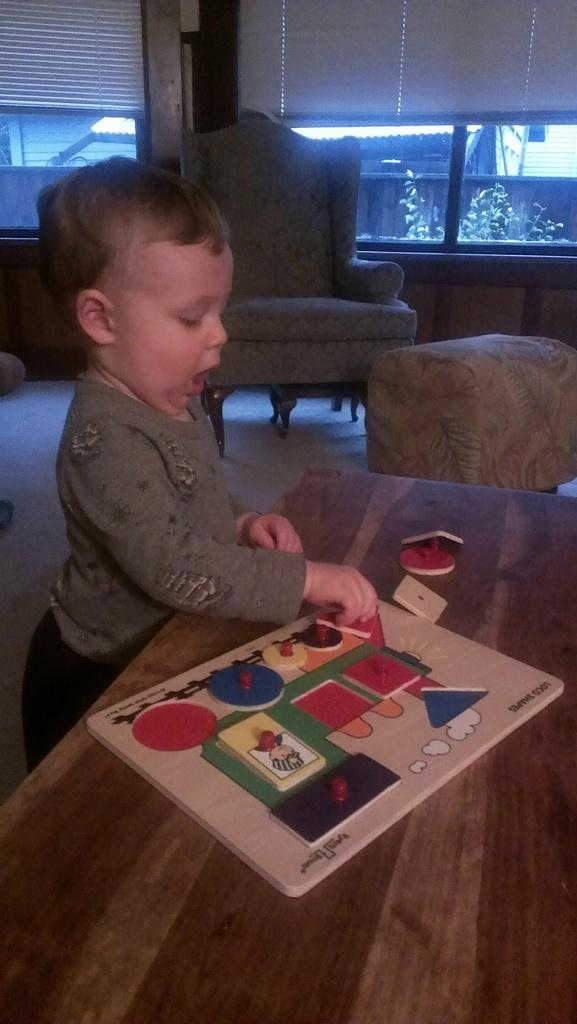Who is the main subject in the image? There is a boy in the image. What is the boy doing in the image? The boy is playing with a toy. Where is the toy located in relation to the boy? The toy is on a table in front of the boy. What type of clam is the boy using as a guide to play with the toy? There is no clam present in the image, and the boy is not using any guide to play with the toy. 